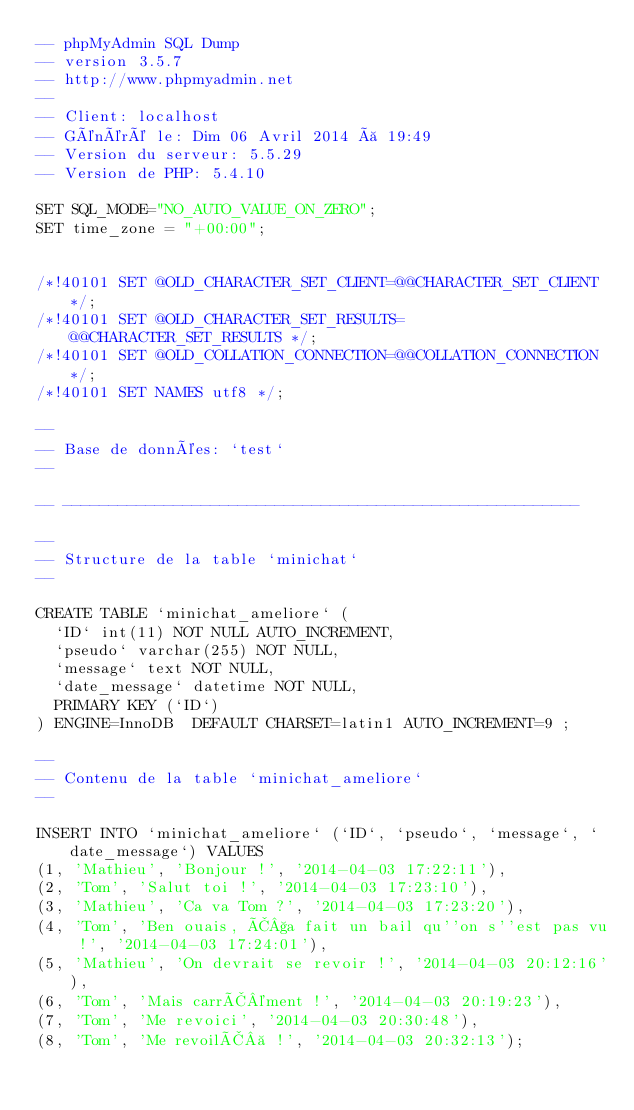Convert code to text. <code><loc_0><loc_0><loc_500><loc_500><_SQL_>-- phpMyAdmin SQL Dump
-- version 3.5.7
-- http://www.phpmyadmin.net
--
-- Client: localhost
-- Généré le: Dim 06 Avril 2014 à 19:49
-- Version du serveur: 5.5.29
-- Version de PHP: 5.4.10

SET SQL_MODE="NO_AUTO_VALUE_ON_ZERO";
SET time_zone = "+00:00";


/*!40101 SET @OLD_CHARACTER_SET_CLIENT=@@CHARACTER_SET_CLIENT */;
/*!40101 SET @OLD_CHARACTER_SET_RESULTS=@@CHARACTER_SET_RESULTS */;
/*!40101 SET @OLD_COLLATION_CONNECTION=@@COLLATION_CONNECTION */;
/*!40101 SET NAMES utf8 */;

--
-- Base de données: `test`
--

-- --------------------------------------------------------

--
-- Structure de la table `minichat`
--

CREATE TABLE `minichat_ameliore` (
  `ID` int(11) NOT NULL AUTO_INCREMENT,
  `pseudo` varchar(255) NOT NULL,
  `message` text NOT NULL,
  `date_message` datetime NOT NULL,
  PRIMARY KEY (`ID`)
) ENGINE=InnoDB  DEFAULT CHARSET=latin1 AUTO_INCREMENT=9 ;

--
-- Contenu de la table `minichat_ameliore`
--

INSERT INTO `minichat_ameliore` (`ID`, `pseudo`, `message`, `date_message`) VALUES
(1, 'Mathieu', 'Bonjour !', '2014-04-03 17:22:11'),
(2, 'Tom', 'Salut toi !', '2014-04-03 17:23:10'),
(3, 'Mathieu', 'Ca va Tom ?', '2014-04-03 17:23:20'),
(4, 'Tom', 'Ben ouais, Ã§a fait un bail qu''on s''est pas vu !', '2014-04-03 17:24:01'),
(5, 'Mathieu', 'On devrait se revoir !', '2014-04-03 20:12:16'),
(6, 'Tom', 'Mais carrÃ©ment !', '2014-04-03 20:19:23'),
(7, 'Tom', 'Me revoici', '2014-04-03 20:30:48'),
(8, 'Tom', 'Me revoilÃ  !', '2014-04-03 20:32:13');
</code> 